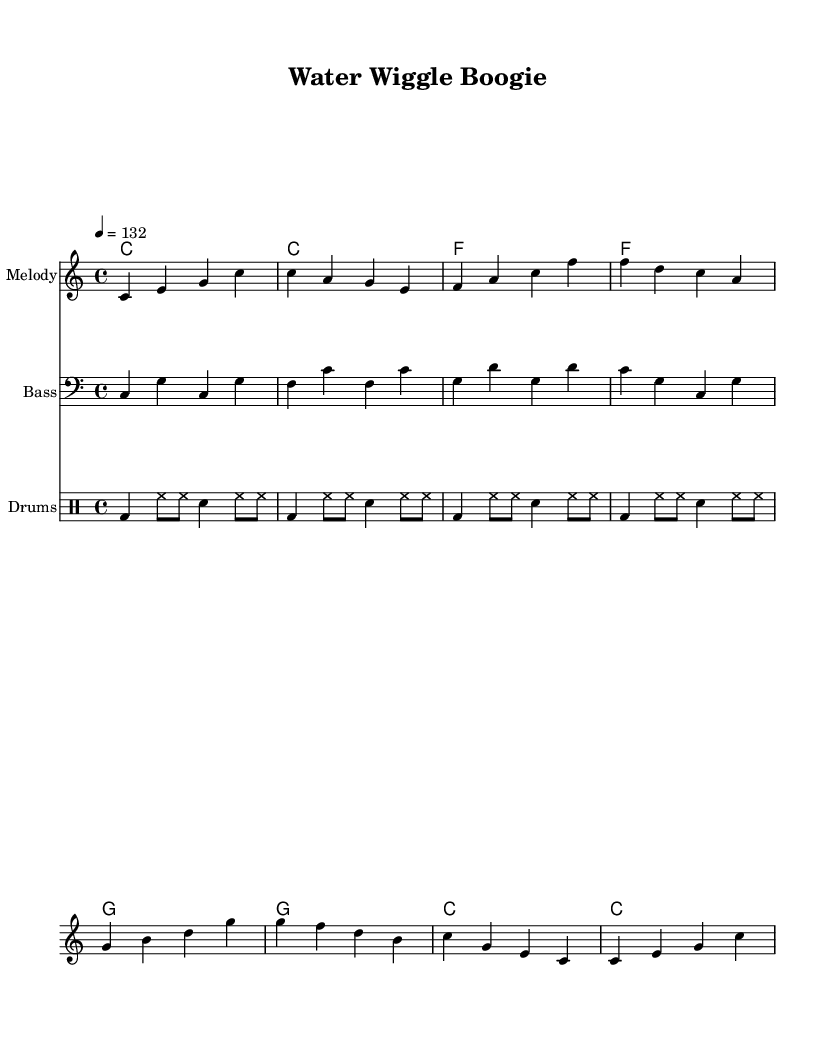What is the key signature of this music? The key signature is C major, which has no sharps or flats.
Answer: C major What is the time signature of this piece? The time signature shown in the sheet music is 4/4, indicating that there are four beats in each measure.
Answer: 4/4 What is the tempo marking for this song? The tempo marking indicates to play at a speed of 132 beats per minute, making it a lively and energetic pace.
Answer: 132 How many measures are in the melody part? By counting the measures in the melody, there are a total of 8 measures present.
Answer: 8 What instruments are included in the arrangement? The music includes a melody, bass, and drum parts, which are common in energetic dance tracks.
Answer: Melody, Bass, Drums What is the first note of the melody? The first note in the melody is a C note, which establishes the starting pitch for the piece.
Answer: C What is the lyric theme of the song? The lyrics reflect a fun and educational theme about drinking water and staying hydrated for health, which aligns with the song's purpose.
Answer: Water and hydration 